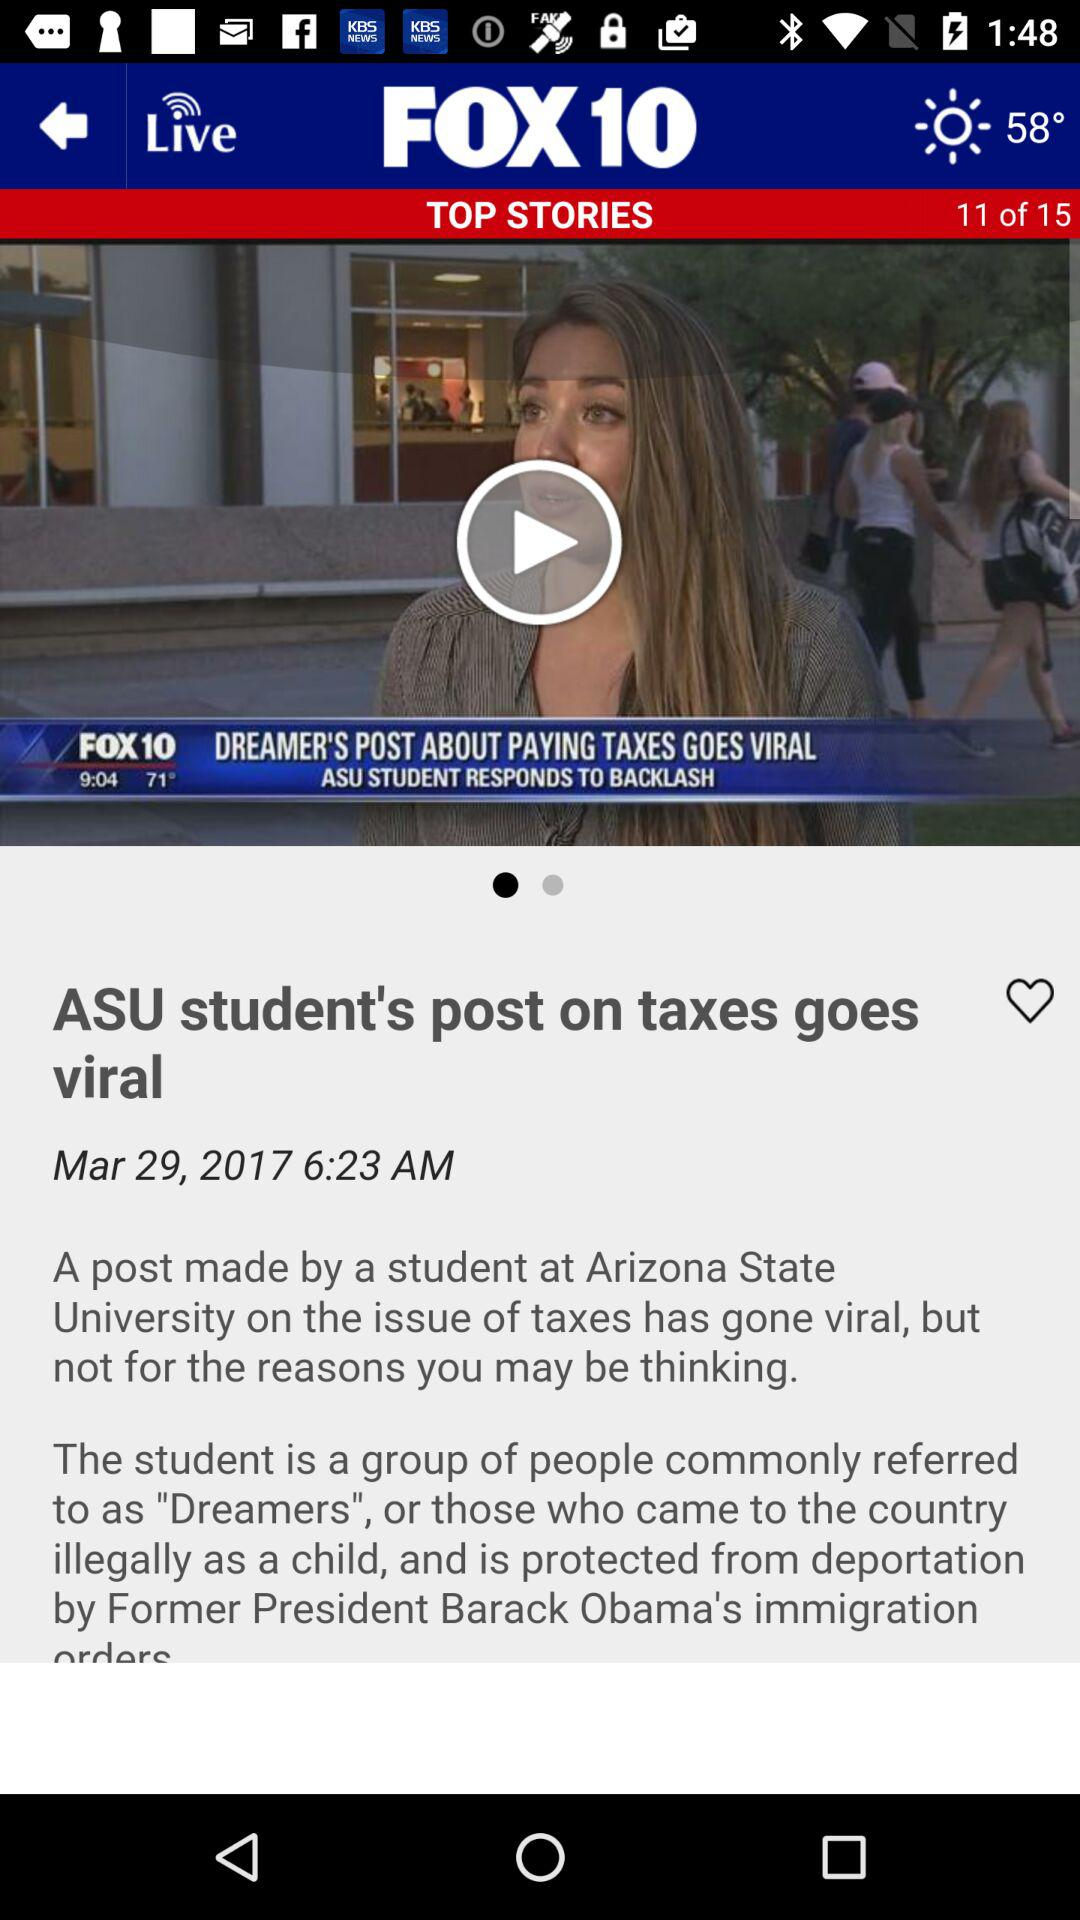What is the current story number? The current story number is 11. 